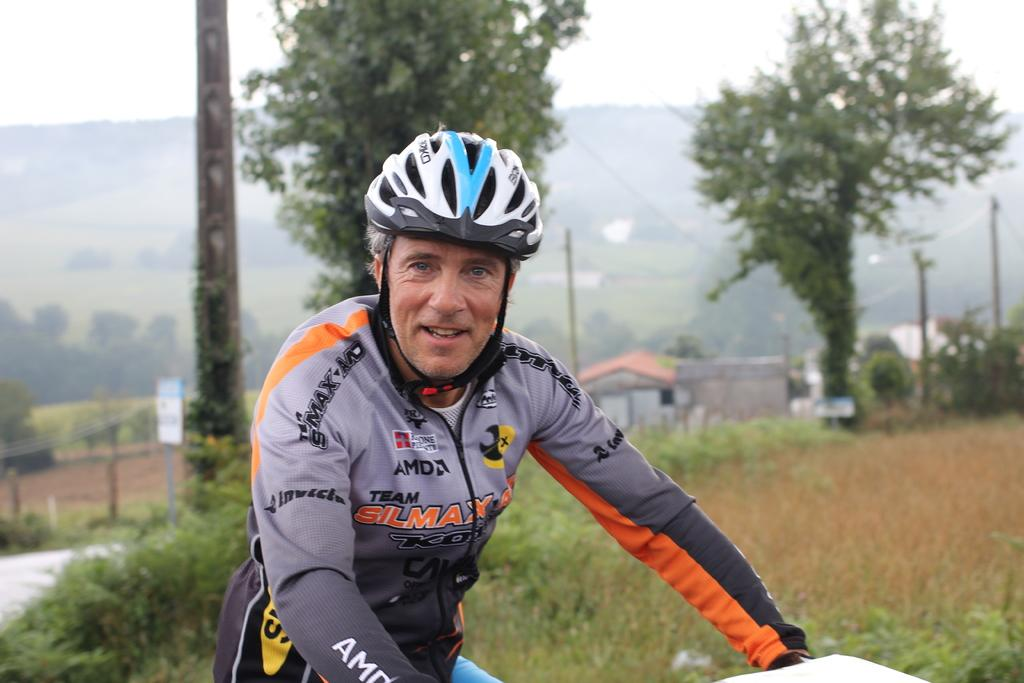Who is present in the image? There is a man in the image. What is the man wearing on his head? The man is wearing a helmet. What can be seen behind the man? There are trees behind the man. What other structures are visible in the image? There are poles and houses in the background. What geographical feature can be seen in the background? There is a hill in the background. What part of the natural environment is visible in the image? The sky is visible in the image. What type of root can be seen growing near the man in the image? There is no root visible in the image; the focus is on the man, his helmet, and the surrounding environment. 